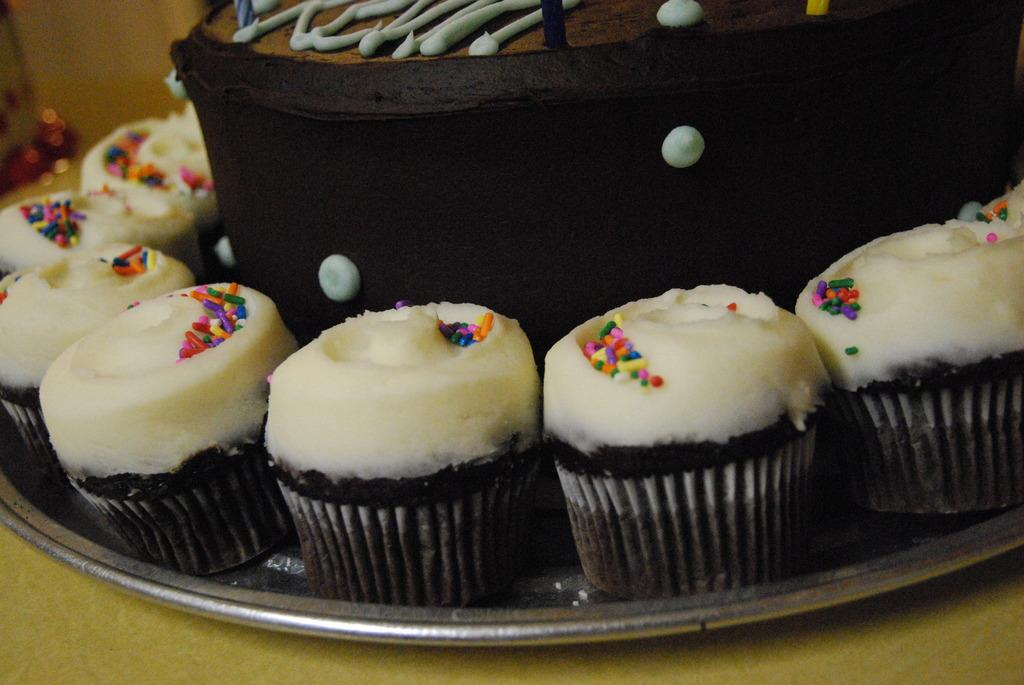What is the main food item featured in the image? There is a cake in the image. What accompanies the cake on the plate? There are cake cups on a plate in the image. On what surface is the plate placed? The plate is placed on a wooden surface. What can be seen on the left side of the image? There are objects on the left side of the image. What type of button is being pushed by the cake in the image? There is no button present in the image, and the cake is not shown interacting with any objects. 